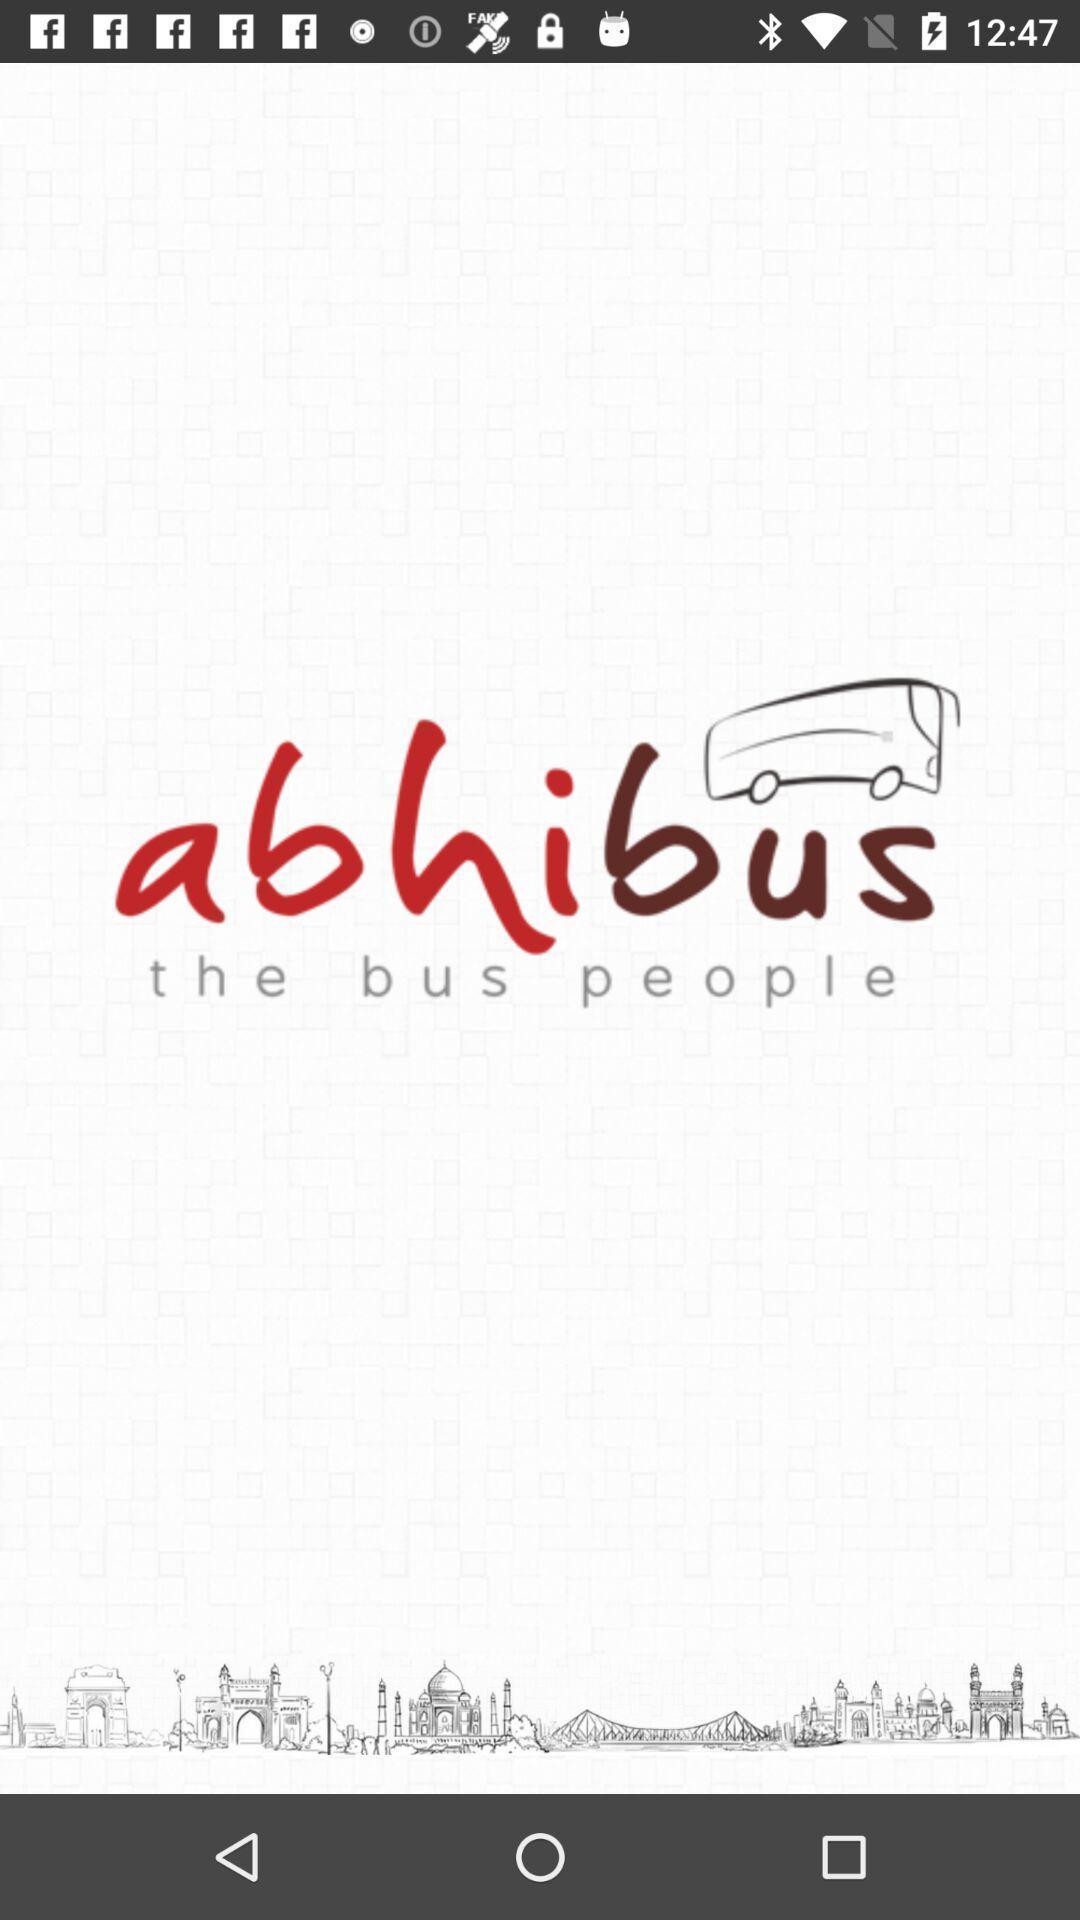Summarize the main components in this picture. Welcome page. 